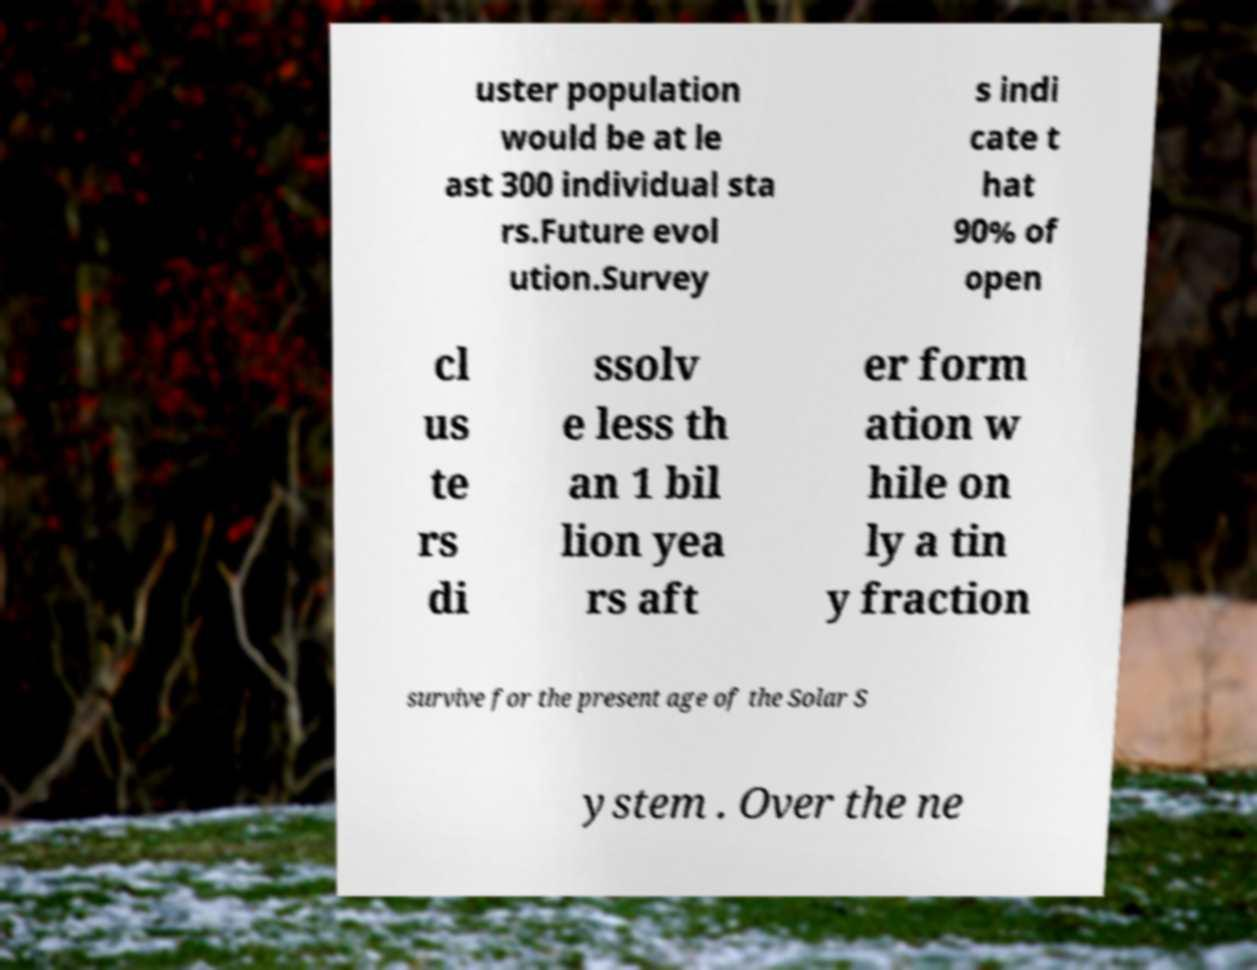What messages or text are displayed in this image? I need them in a readable, typed format. uster population would be at le ast 300 individual sta rs.Future evol ution.Survey s indi cate t hat 90% of open cl us te rs di ssolv e less th an 1 bil lion yea rs aft er form ation w hile on ly a tin y fraction survive for the present age of the Solar S ystem . Over the ne 